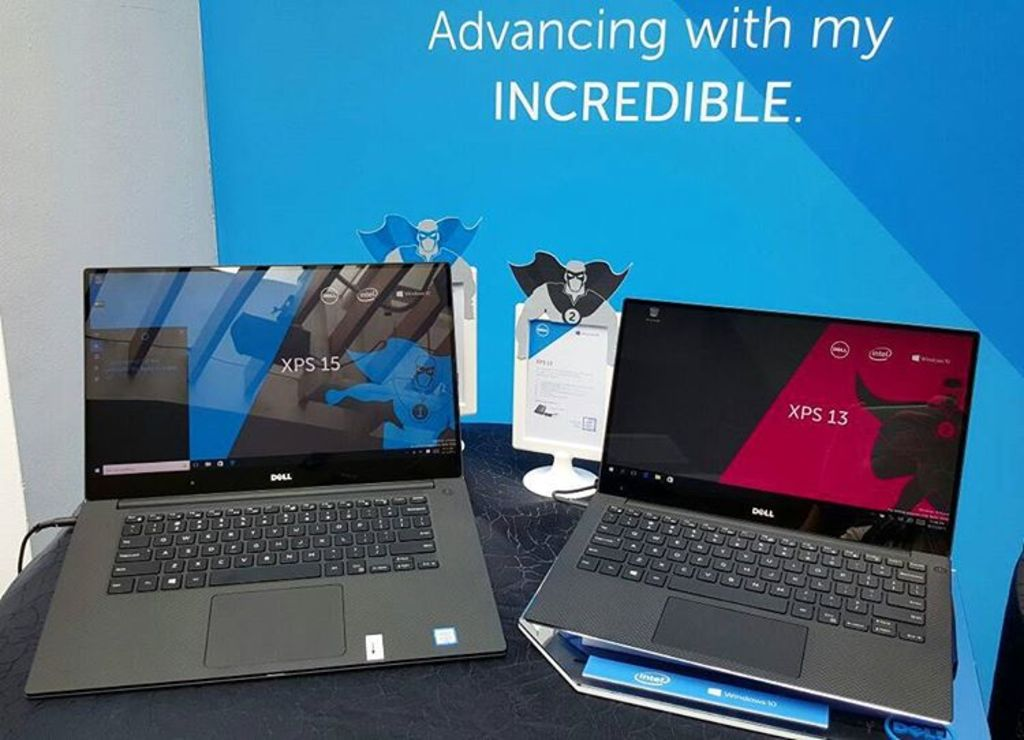Can you tell me how the aesthetics of these laptops align with current technology trends? The sleek, minimalist design of both laptops with thin bezels and a sturdy, stylish chassis reflects current trends in technology, emphasizing portability and modern elegance that appeals to both business professionals and creatives. How do these aesthetics potentially affect the user experience? The refined aesthetics not only enhance the visual appeal but also contribute to a more immersive user experience, with larger screen real estate in a compact body designed to increase productivity and user comfort during extended periods of use. 